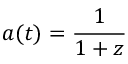<formula> <loc_0><loc_0><loc_500><loc_500>a ( t ) = { \frac { 1 } { 1 + z } }</formula> 